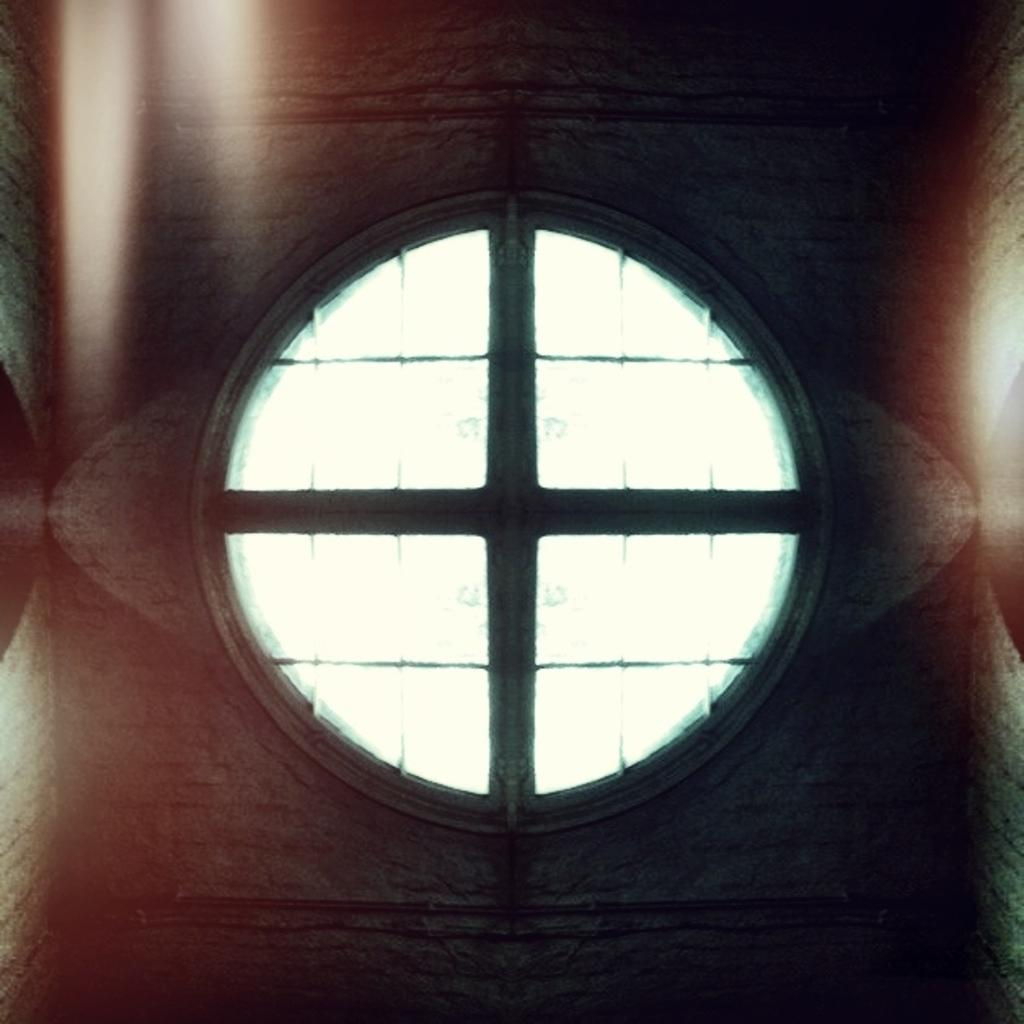What type of structure can be seen in the image? There is a wall in the image. What material is used for the windows in the image? The windows in the image are made of glass. What type of writing can be seen on the wall in the image? There is no writing visible on the wall in the image. How many chairs are present in the image? There is no information about chairs in the provided facts, so we cannot determine the number of chairs in the image. 